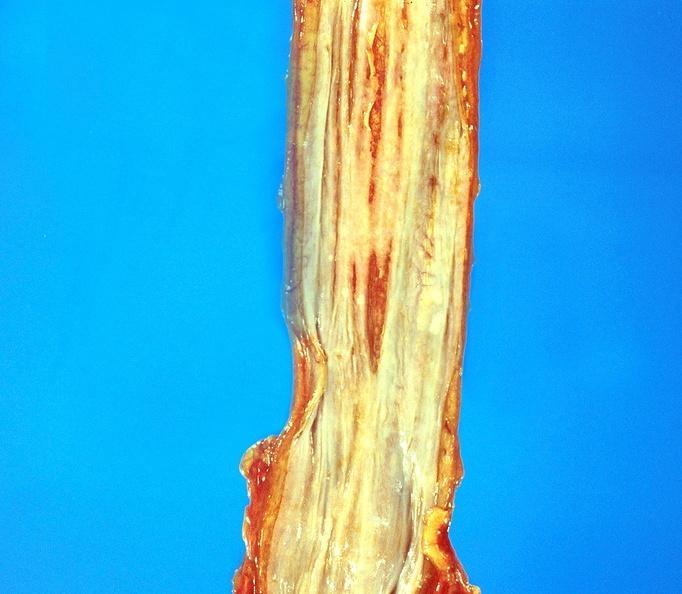what is present?
Answer the question using a single word or phrase. Gastrointestinal 